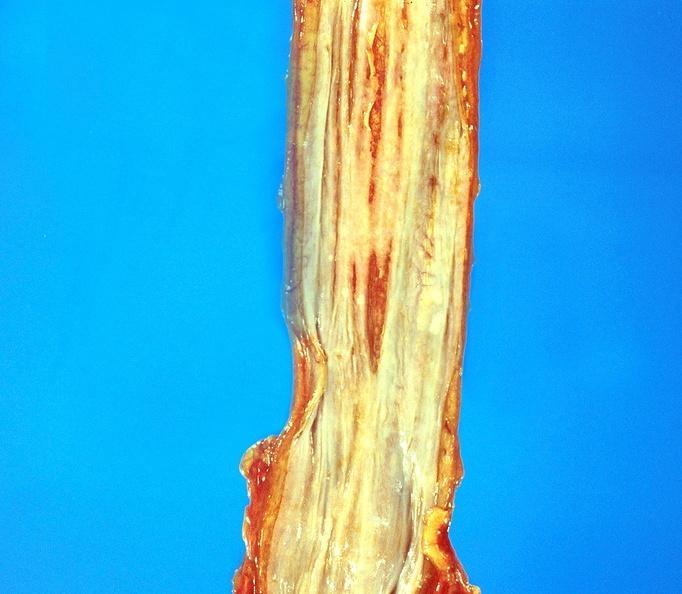what is present?
Answer the question using a single word or phrase. Gastrointestinal 